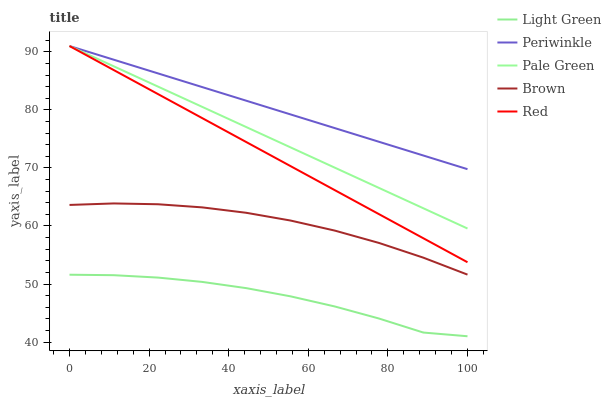Does Light Green have the minimum area under the curve?
Answer yes or no. Yes. Does Periwinkle have the maximum area under the curve?
Answer yes or no. Yes. Does Pale Green have the minimum area under the curve?
Answer yes or no. No. Does Pale Green have the maximum area under the curve?
Answer yes or no. No. Is Periwinkle the smoothest?
Answer yes or no. Yes. Is Light Green the roughest?
Answer yes or no. Yes. Is Pale Green the smoothest?
Answer yes or no. No. Is Pale Green the roughest?
Answer yes or no. No. Does Pale Green have the lowest value?
Answer yes or no. No. Does Light Green have the highest value?
Answer yes or no. No. Is Light Green less than Red?
Answer yes or no. Yes. Is Periwinkle greater than Brown?
Answer yes or no. Yes. Does Light Green intersect Red?
Answer yes or no. No. 